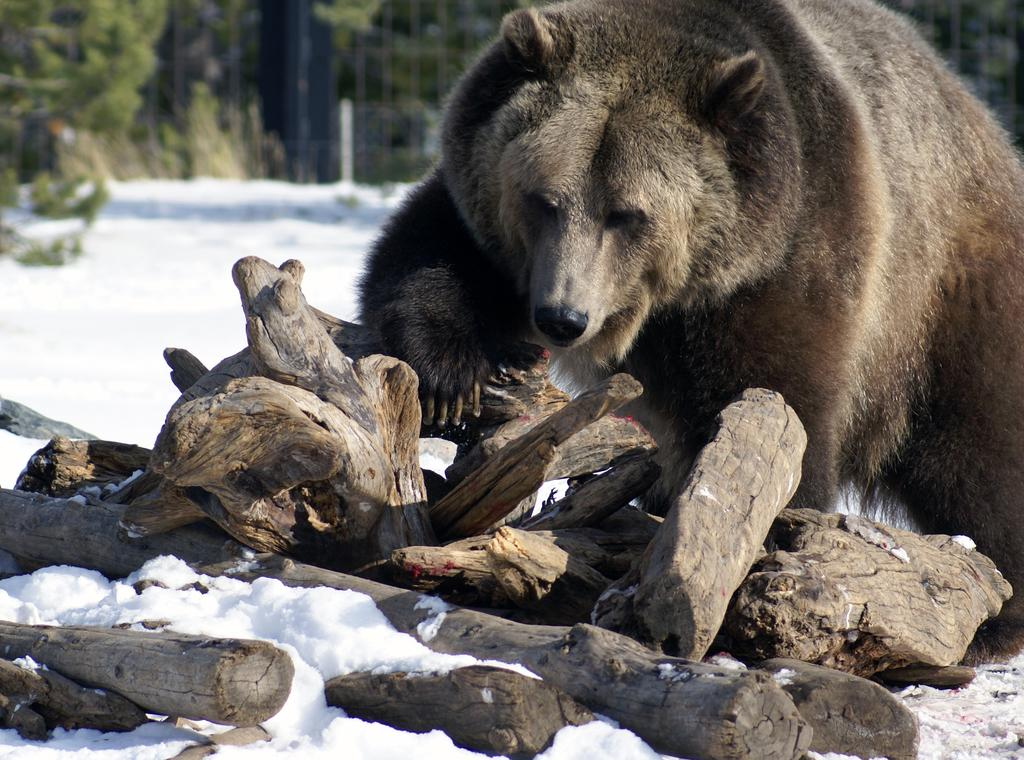What animal is present in the image? There is a bear in the image. What is the bear near in the image? The bear is near wooden sticks. What is the setting of the image? The scene takes place on snow. What can be seen in the background of the image? There are trees, plants, and a pole in the background of the image. How is the background of the image depicted? The background has a blurry view. What type of teeth can be seen on the bear in the image? Bears do not have teeth visible in the image; they have mouths that are not open or showing teeth. What nut is the bear trying to crack with the wooden sticks in the image? There is no nut present in the image, nor is the bear shown attempting to crack one. 